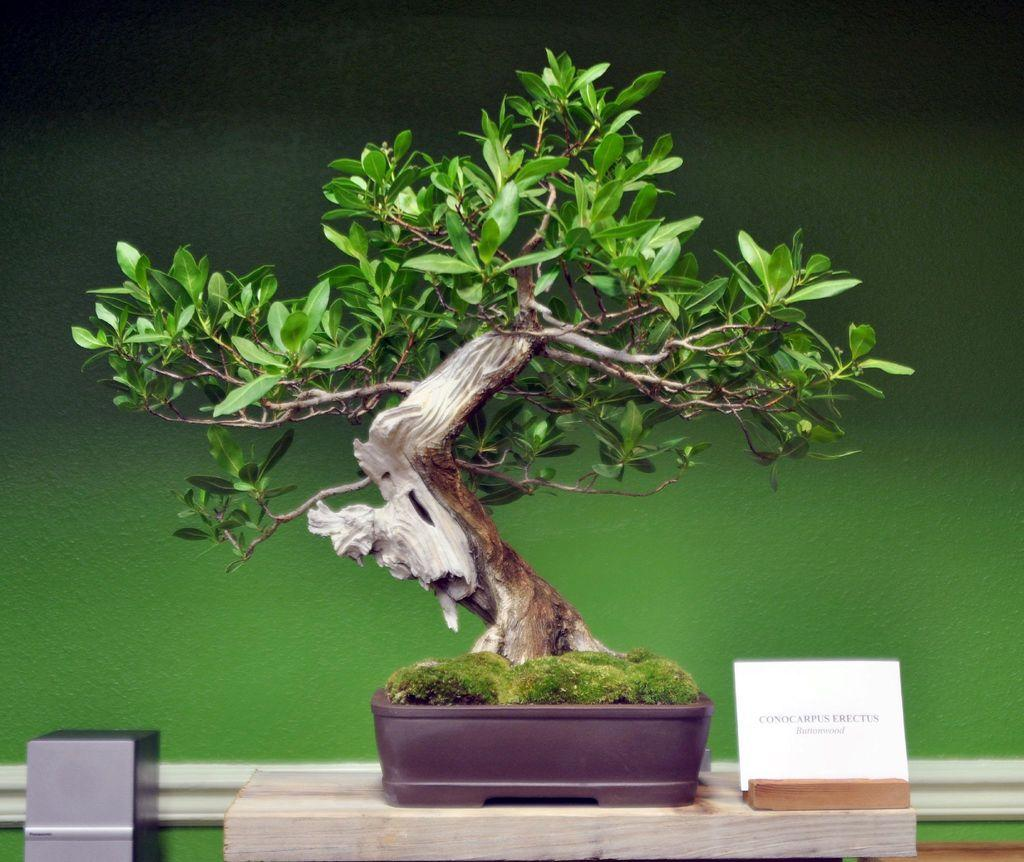What type of plant is in the image? There is a bonsai tree in the image. What else can be seen on the table in the image? There is a label on the table in the image. What is visible in the background of the image? There is a wall in the background of the image. How many snakes are wrapped around the bonsai tree in the image? There are no snakes present in the image; it features a bonsai tree and a label on a table. What type of lace is draped over the bonsai tree in the image? There is no lace present in the image; it only features a bonsai tree and a label on a table. 